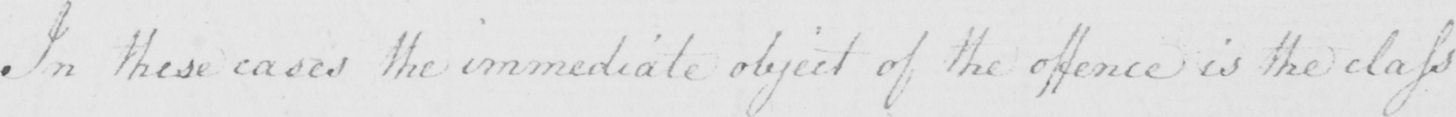What does this handwritten line say? In these cases the immediate object of the offence is the class 